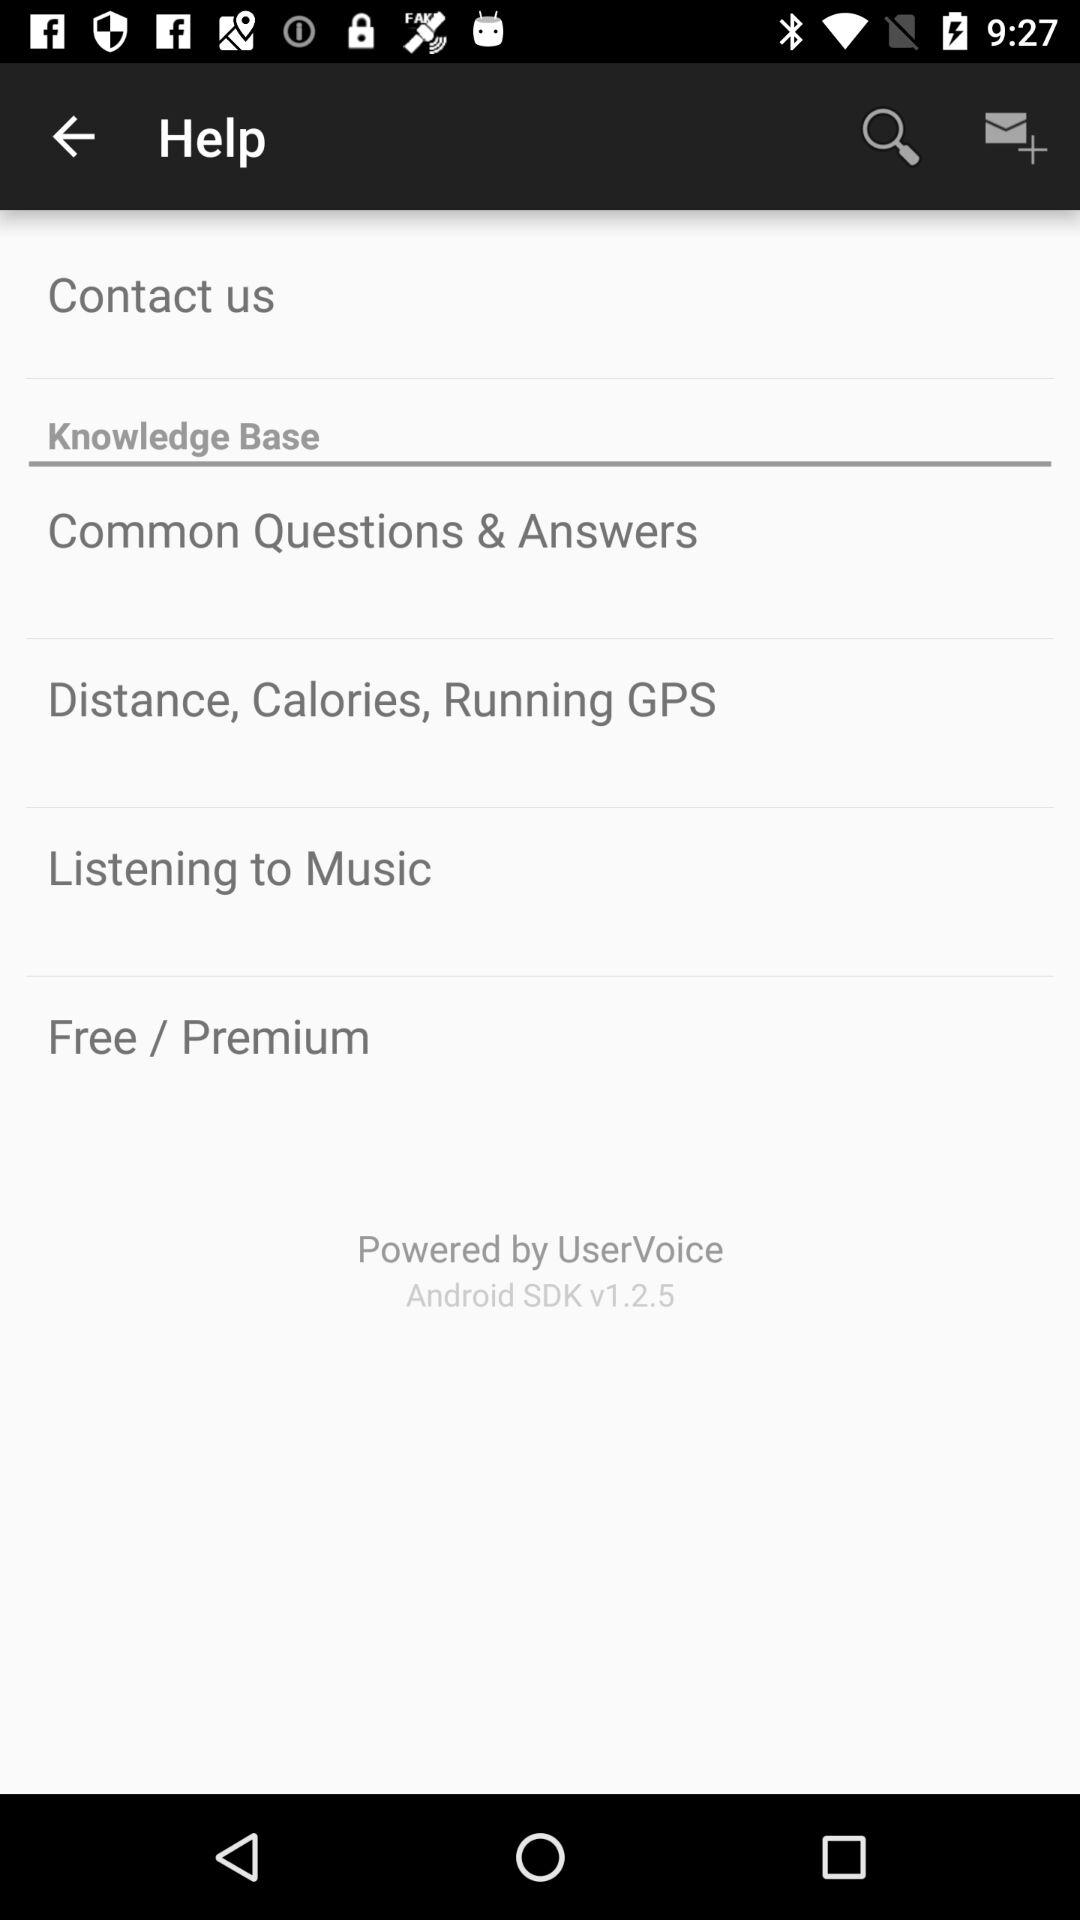What android version is used? The Android version is SDK v1.2.5. 